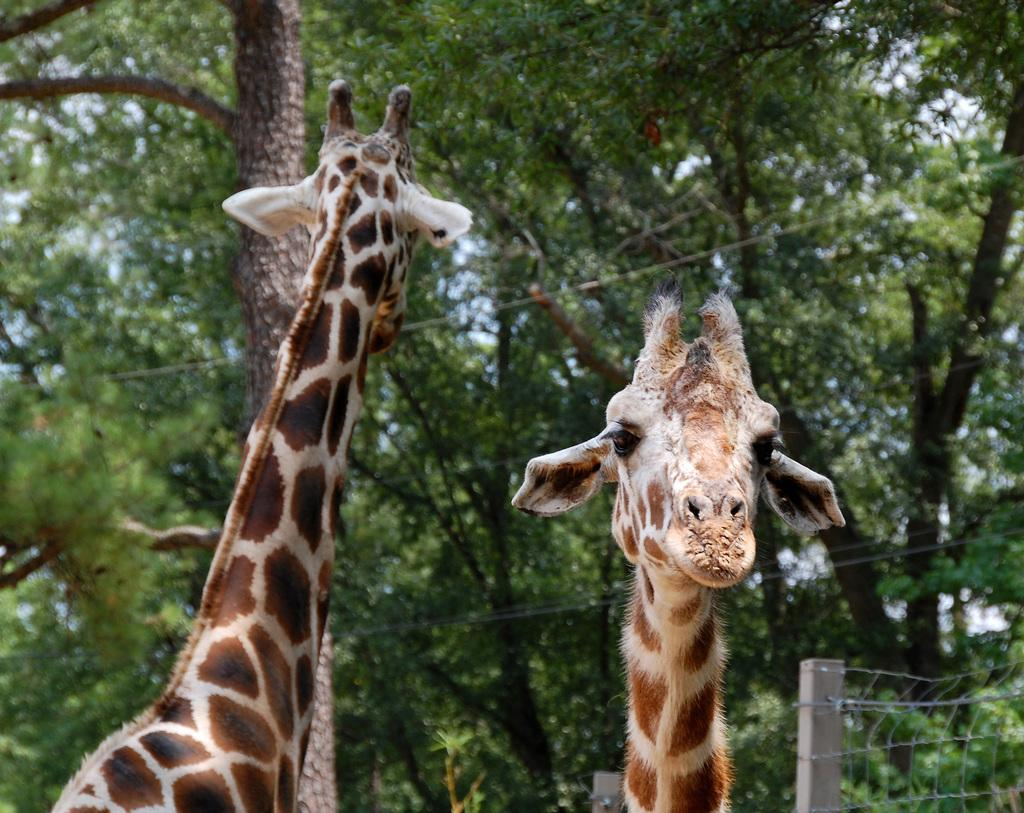How many giraffes are in the image? There are two giraffes in the image. What can be seen in the background of the image? There are trees in the background of the image. What is on the right side of the image? There is a metal grill fence on the right side of the image. What type of can is visible in the image? There is no can present in the image. How does the giraffe's digestion process work in the image? The image does not show the giraffes' digestion process, so it cannot be determined from the image. 